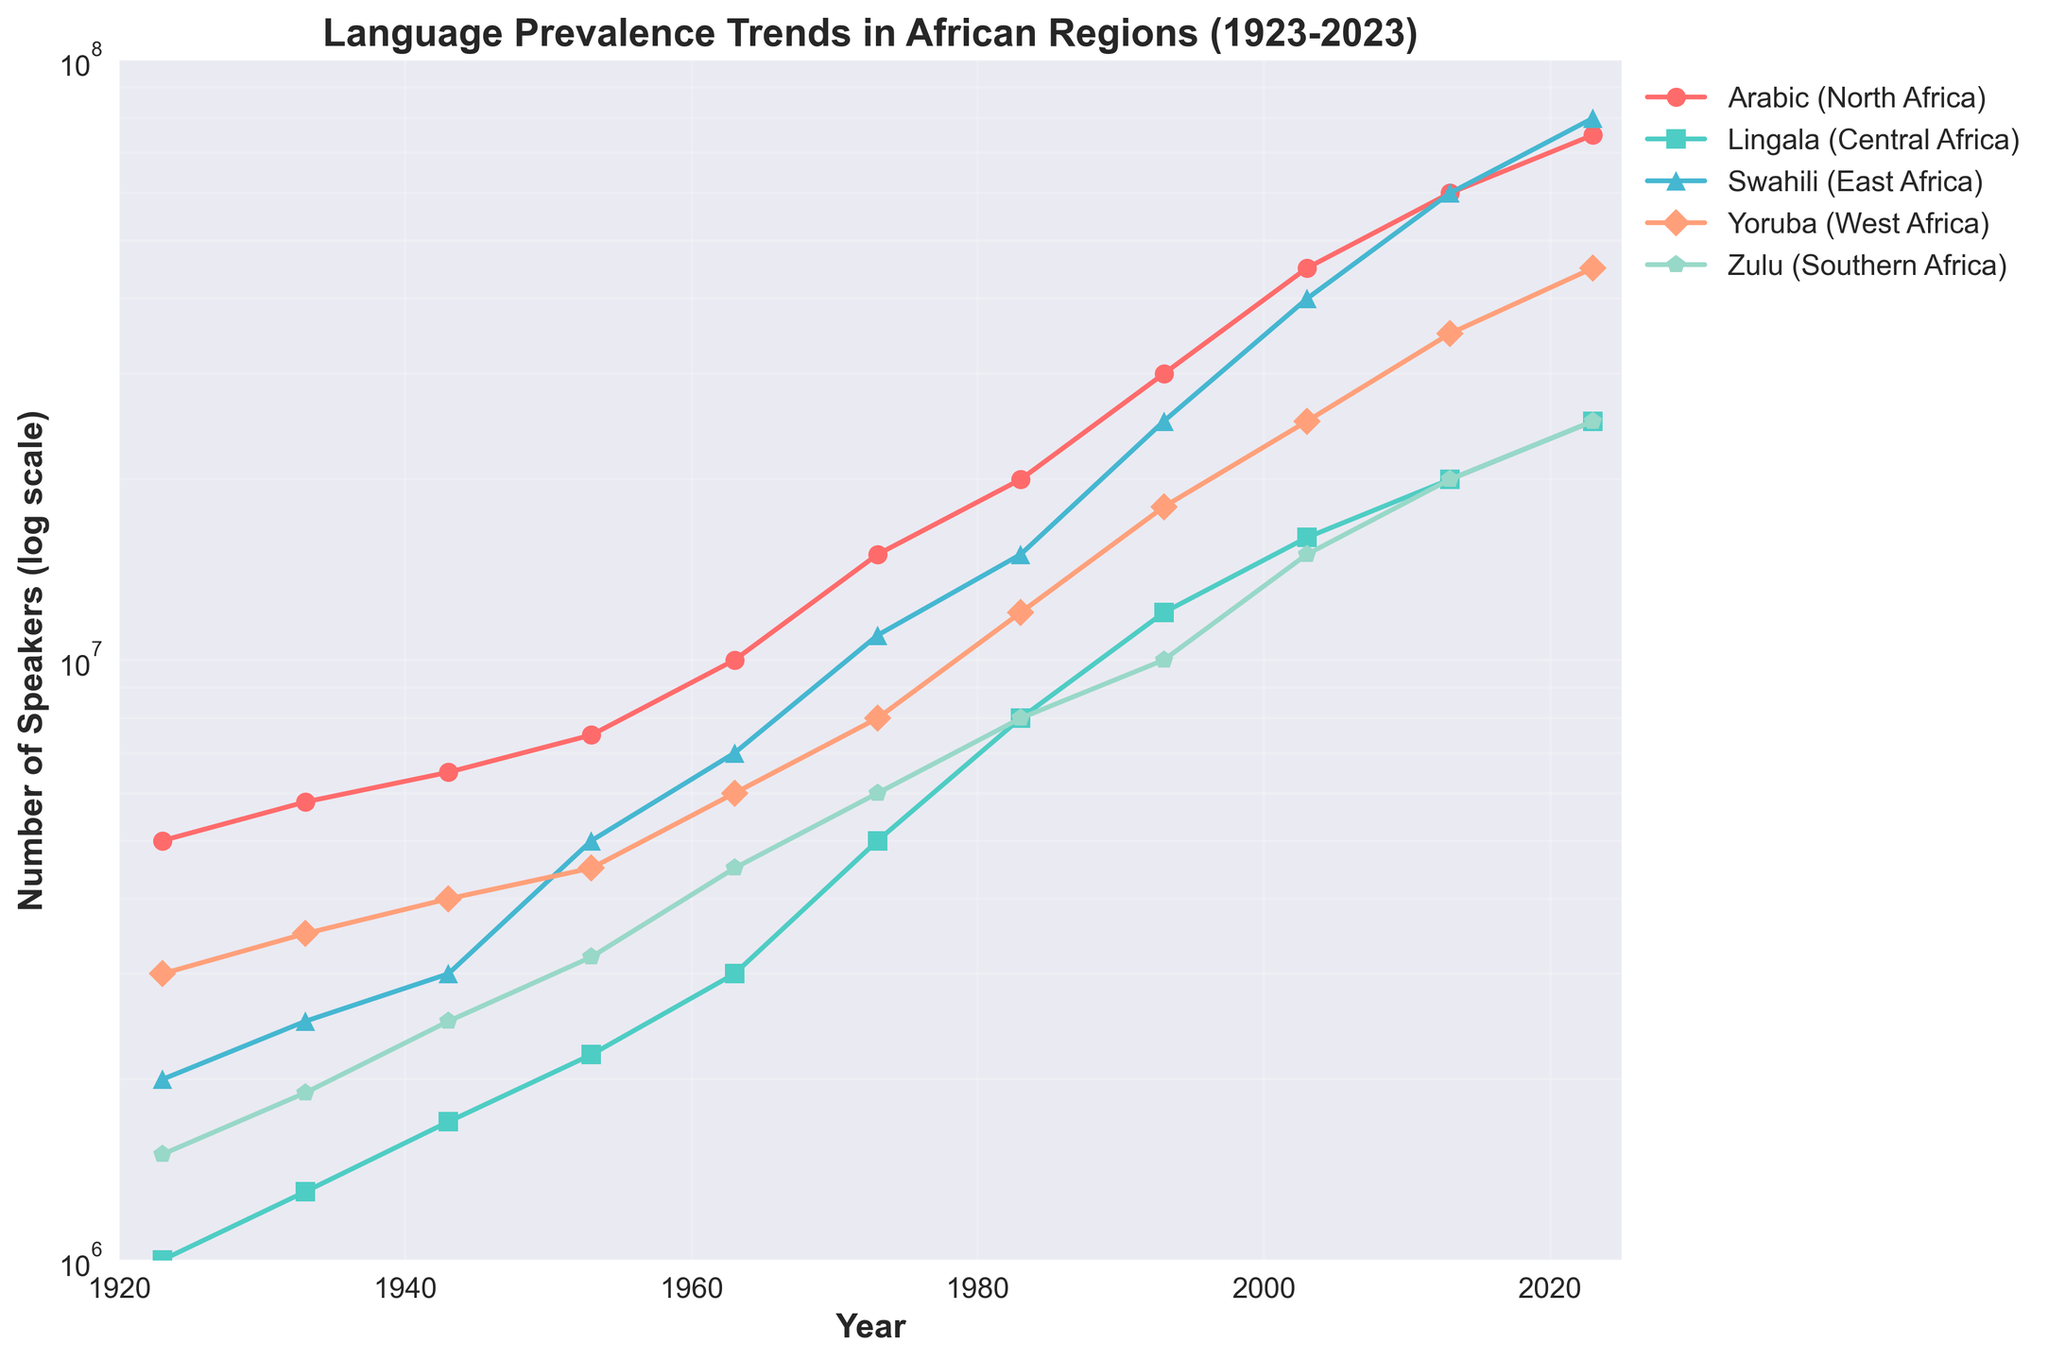Which region sees the highest number of speakers for its language in 2023? By examining the end point of the lines in 2023, Swahili in East Africa reaches approximately 80,000,000 speakers, which is the highest among all regions.
Answer: East Africa How many speakers did Yoruba have in 1983? Locate the year 1983 along the x-axis. The plot for Yoruba shows a point at 12,000,000 speakers for that year.
Answer: 12,000,000 Between which years did Zulu in Southern Africa see the greatest increase in the number of speakers? Observing the steepness of the lines on the log scale, the sharpest increase for Zulu appears between 1993 and 2003, where it jumps from 10,000,000 to 15,000,000 speakers.
Answer: 1993-2003 Which language shows the most consistent exponential growth over the century? Examining the straightest line on the log scale, Swahili in East Africa shows a very consistent and steep exponential growth.
Answer: Swahili In which decade did Arabic in North Africa reach 10 million speakers? Find the point where Arabic surpasses 10 million on the y-axis. This occurs around the 1960s.
Answer: 1960s What is the ratio of speakers for Lingala in Central Africa to Zulu in Southern Africa in 2023? For 2023, Lingala has 25,000,000 speakers and Zulu has 25,000,000. Thus, the ratio is 25,000,000:25,000,000 or 1:1.
Answer: 1:1 Which language experienced the largest absolute increase in the number of speakers from 1923 to 2023? By calculating the difference between the initial and final number of speakers, Swahili grew from 2,000,000 in 1923 to 80,000,000 in 2023, a difference of 78,000,000, the largest increase.
Answer: Swahili What was the number of speakers for Lingala in 1943? Locate the year 1943 on the x-axis. The plot for Lingala shows a point at approximately 1,700,000 speakers for that year.
Answer: 1,700,000 How does the growth in the number of speakers for Yoruba compare with that of Arabic over the entire period? By viewing the lines for Yoruba and Arabic, it's evident that both exhibit rapid exponential growth, yet Yoruba reaches 45 million by 2023, while Arabic reaches 75 million, indicating Arabic had a higher growth.
Answer: Arabic > Yoruba 